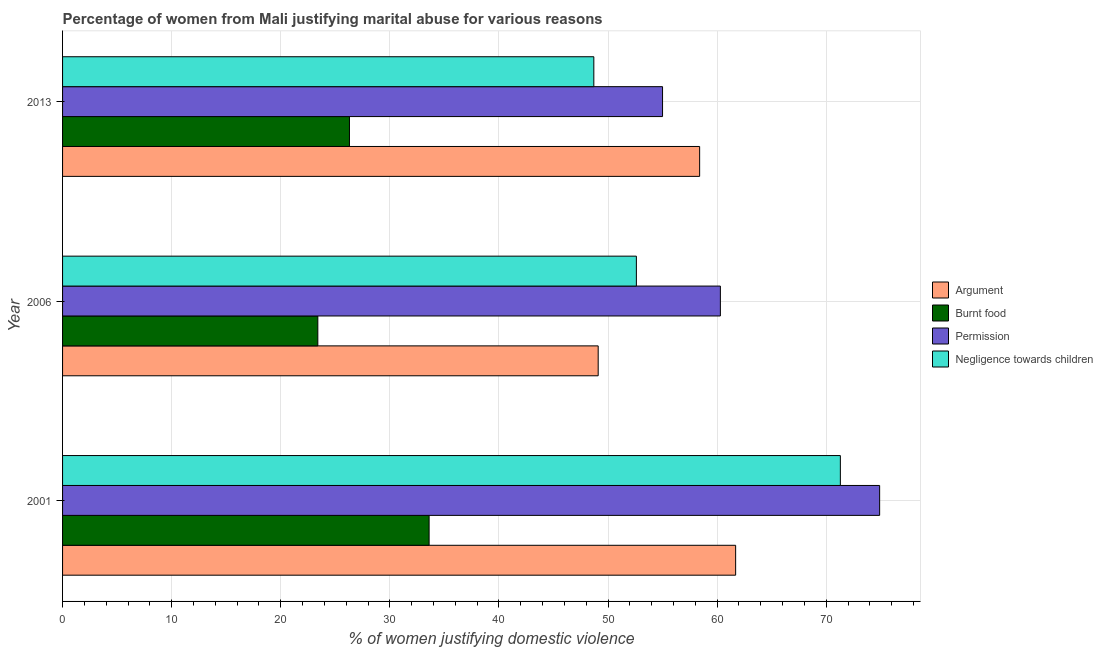How many different coloured bars are there?
Provide a succinct answer. 4. How many groups of bars are there?
Offer a terse response. 3. Are the number of bars per tick equal to the number of legend labels?
Offer a very short reply. Yes. Are the number of bars on each tick of the Y-axis equal?
Your response must be concise. Yes. How many bars are there on the 3rd tick from the bottom?
Your answer should be very brief. 4. In how many cases, is the number of bars for a given year not equal to the number of legend labels?
Provide a succinct answer. 0. What is the percentage of women justifying abuse in the case of an argument in 2001?
Offer a very short reply. 61.7. Across all years, what is the maximum percentage of women justifying abuse in the case of an argument?
Your answer should be very brief. 61.7. Across all years, what is the minimum percentage of women justifying abuse in the case of an argument?
Keep it short and to the point. 49.1. In which year was the percentage of women justifying abuse for burning food maximum?
Offer a terse response. 2001. In which year was the percentage of women justifying abuse for burning food minimum?
Offer a terse response. 2006. What is the total percentage of women justifying abuse in the case of an argument in the graph?
Provide a succinct answer. 169.2. What is the difference between the percentage of women justifying abuse for burning food in 2001 and that in 2013?
Keep it short and to the point. 7.3. What is the difference between the percentage of women justifying abuse in the case of an argument in 2006 and the percentage of women justifying abuse for burning food in 2013?
Provide a succinct answer. 22.8. What is the average percentage of women justifying abuse for burning food per year?
Provide a succinct answer. 27.77. In the year 2001, what is the difference between the percentage of women justifying abuse for burning food and percentage of women justifying abuse in the case of an argument?
Make the answer very short. -28.1. What is the ratio of the percentage of women justifying abuse for burning food in 2006 to that in 2013?
Make the answer very short. 0.89. In how many years, is the percentage of women justifying abuse for showing negligence towards children greater than the average percentage of women justifying abuse for showing negligence towards children taken over all years?
Offer a very short reply. 1. Is the sum of the percentage of women justifying abuse for showing negligence towards children in 2001 and 2006 greater than the maximum percentage of women justifying abuse for burning food across all years?
Offer a terse response. Yes. What does the 3rd bar from the top in 2001 represents?
Your answer should be very brief. Burnt food. What does the 4th bar from the bottom in 2013 represents?
Offer a very short reply. Negligence towards children. How many bars are there?
Your answer should be very brief. 12. How many years are there in the graph?
Make the answer very short. 3. What is the difference between two consecutive major ticks on the X-axis?
Your response must be concise. 10. Where does the legend appear in the graph?
Provide a short and direct response. Center right. How many legend labels are there?
Offer a terse response. 4. What is the title of the graph?
Give a very brief answer. Percentage of women from Mali justifying marital abuse for various reasons. Does "Iceland" appear as one of the legend labels in the graph?
Provide a short and direct response. No. What is the label or title of the X-axis?
Make the answer very short. % of women justifying domestic violence. What is the label or title of the Y-axis?
Provide a succinct answer. Year. What is the % of women justifying domestic violence in Argument in 2001?
Keep it short and to the point. 61.7. What is the % of women justifying domestic violence of Burnt food in 2001?
Provide a short and direct response. 33.6. What is the % of women justifying domestic violence of Permission in 2001?
Keep it short and to the point. 74.9. What is the % of women justifying domestic violence in Negligence towards children in 2001?
Your answer should be very brief. 71.3. What is the % of women justifying domestic violence of Argument in 2006?
Your response must be concise. 49.1. What is the % of women justifying domestic violence in Burnt food in 2006?
Your answer should be compact. 23.4. What is the % of women justifying domestic violence in Permission in 2006?
Your response must be concise. 60.3. What is the % of women justifying domestic violence of Negligence towards children in 2006?
Your response must be concise. 52.6. What is the % of women justifying domestic violence in Argument in 2013?
Provide a short and direct response. 58.4. What is the % of women justifying domestic violence in Burnt food in 2013?
Your answer should be compact. 26.3. What is the % of women justifying domestic violence in Permission in 2013?
Make the answer very short. 55. What is the % of women justifying domestic violence in Negligence towards children in 2013?
Provide a succinct answer. 48.7. Across all years, what is the maximum % of women justifying domestic violence of Argument?
Give a very brief answer. 61.7. Across all years, what is the maximum % of women justifying domestic violence in Burnt food?
Provide a succinct answer. 33.6. Across all years, what is the maximum % of women justifying domestic violence in Permission?
Your response must be concise. 74.9. Across all years, what is the maximum % of women justifying domestic violence in Negligence towards children?
Offer a terse response. 71.3. Across all years, what is the minimum % of women justifying domestic violence of Argument?
Make the answer very short. 49.1. Across all years, what is the minimum % of women justifying domestic violence of Burnt food?
Your response must be concise. 23.4. Across all years, what is the minimum % of women justifying domestic violence of Permission?
Give a very brief answer. 55. Across all years, what is the minimum % of women justifying domestic violence in Negligence towards children?
Give a very brief answer. 48.7. What is the total % of women justifying domestic violence in Argument in the graph?
Your answer should be compact. 169.2. What is the total % of women justifying domestic violence in Burnt food in the graph?
Offer a very short reply. 83.3. What is the total % of women justifying domestic violence in Permission in the graph?
Provide a short and direct response. 190.2. What is the total % of women justifying domestic violence of Negligence towards children in the graph?
Provide a short and direct response. 172.6. What is the difference between the % of women justifying domestic violence in Argument in 2001 and that in 2006?
Provide a short and direct response. 12.6. What is the difference between the % of women justifying domestic violence in Permission in 2001 and that in 2006?
Your answer should be compact. 14.6. What is the difference between the % of women justifying domestic violence in Argument in 2001 and that in 2013?
Your answer should be compact. 3.3. What is the difference between the % of women justifying domestic violence of Negligence towards children in 2001 and that in 2013?
Give a very brief answer. 22.6. What is the difference between the % of women justifying domestic violence of Negligence towards children in 2006 and that in 2013?
Provide a short and direct response. 3.9. What is the difference between the % of women justifying domestic violence in Argument in 2001 and the % of women justifying domestic violence in Burnt food in 2006?
Your response must be concise. 38.3. What is the difference between the % of women justifying domestic violence in Argument in 2001 and the % of women justifying domestic violence in Negligence towards children in 2006?
Your answer should be compact. 9.1. What is the difference between the % of women justifying domestic violence of Burnt food in 2001 and the % of women justifying domestic violence of Permission in 2006?
Offer a terse response. -26.7. What is the difference between the % of women justifying domestic violence of Burnt food in 2001 and the % of women justifying domestic violence of Negligence towards children in 2006?
Ensure brevity in your answer.  -19. What is the difference between the % of women justifying domestic violence in Permission in 2001 and the % of women justifying domestic violence in Negligence towards children in 2006?
Give a very brief answer. 22.3. What is the difference between the % of women justifying domestic violence of Argument in 2001 and the % of women justifying domestic violence of Burnt food in 2013?
Provide a short and direct response. 35.4. What is the difference between the % of women justifying domestic violence in Argument in 2001 and the % of women justifying domestic violence in Negligence towards children in 2013?
Your answer should be compact. 13. What is the difference between the % of women justifying domestic violence of Burnt food in 2001 and the % of women justifying domestic violence of Permission in 2013?
Ensure brevity in your answer.  -21.4. What is the difference between the % of women justifying domestic violence of Burnt food in 2001 and the % of women justifying domestic violence of Negligence towards children in 2013?
Your answer should be very brief. -15.1. What is the difference between the % of women justifying domestic violence of Permission in 2001 and the % of women justifying domestic violence of Negligence towards children in 2013?
Ensure brevity in your answer.  26.2. What is the difference between the % of women justifying domestic violence in Argument in 2006 and the % of women justifying domestic violence in Burnt food in 2013?
Your answer should be very brief. 22.8. What is the difference between the % of women justifying domestic violence in Burnt food in 2006 and the % of women justifying domestic violence in Permission in 2013?
Your answer should be very brief. -31.6. What is the difference between the % of women justifying domestic violence of Burnt food in 2006 and the % of women justifying domestic violence of Negligence towards children in 2013?
Make the answer very short. -25.3. What is the average % of women justifying domestic violence in Argument per year?
Your answer should be compact. 56.4. What is the average % of women justifying domestic violence in Burnt food per year?
Your response must be concise. 27.77. What is the average % of women justifying domestic violence of Permission per year?
Offer a very short reply. 63.4. What is the average % of women justifying domestic violence in Negligence towards children per year?
Ensure brevity in your answer.  57.53. In the year 2001, what is the difference between the % of women justifying domestic violence in Argument and % of women justifying domestic violence in Burnt food?
Offer a terse response. 28.1. In the year 2001, what is the difference between the % of women justifying domestic violence in Burnt food and % of women justifying domestic violence in Permission?
Provide a short and direct response. -41.3. In the year 2001, what is the difference between the % of women justifying domestic violence of Burnt food and % of women justifying domestic violence of Negligence towards children?
Ensure brevity in your answer.  -37.7. In the year 2001, what is the difference between the % of women justifying domestic violence in Permission and % of women justifying domestic violence in Negligence towards children?
Your response must be concise. 3.6. In the year 2006, what is the difference between the % of women justifying domestic violence in Argument and % of women justifying domestic violence in Burnt food?
Offer a terse response. 25.7. In the year 2006, what is the difference between the % of women justifying domestic violence in Argument and % of women justifying domestic violence in Permission?
Give a very brief answer. -11.2. In the year 2006, what is the difference between the % of women justifying domestic violence in Burnt food and % of women justifying domestic violence in Permission?
Provide a short and direct response. -36.9. In the year 2006, what is the difference between the % of women justifying domestic violence of Burnt food and % of women justifying domestic violence of Negligence towards children?
Give a very brief answer. -29.2. In the year 2013, what is the difference between the % of women justifying domestic violence in Argument and % of women justifying domestic violence in Burnt food?
Make the answer very short. 32.1. In the year 2013, what is the difference between the % of women justifying domestic violence in Argument and % of women justifying domestic violence in Permission?
Provide a succinct answer. 3.4. In the year 2013, what is the difference between the % of women justifying domestic violence of Burnt food and % of women justifying domestic violence of Permission?
Your response must be concise. -28.7. In the year 2013, what is the difference between the % of women justifying domestic violence in Burnt food and % of women justifying domestic violence in Negligence towards children?
Give a very brief answer. -22.4. What is the ratio of the % of women justifying domestic violence in Argument in 2001 to that in 2006?
Make the answer very short. 1.26. What is the ratio of the % of women justifying domestic violence in Burnt food in 2001 to that in 2006?
Provide a short and direct response. 1.44. What is the ratio of the % of women justifying domestic violence in Permission in 2001 to that in 2006?
Your response must be concise. 1.24. What is the ratio of the % of women justifying domestic violence of Negligence towards children in 2001 to that in 2006?
Your answer should be very brief. 1.36. What is the ratio of the % of women justifying domestic violence in Argument in 2001 to that in 2013?
Offer a terse response. 1.06. What is the ratio of the % of women justifying domestic violence of Burnt food in 2001 to that in 2013?
Ensure brevity in your answer.  1.28. What is the ratio of the % of women justifying domestic violence in Permission in 2001 to that in 2013?
Provide a succinct answer. 1.36. What is the ratio of the % of women justifying domestic violence in Negligence towards children in 2001 to that in 2013?
Give a very brief answer. 1.46. What is the ratio of the % of women justifying domestic violence of Argument in 2006 to that in 2013?
Keep it short and to the point. 0.84. What is the ratio of the % of women justifying domestic violence in Burnt food in 2006 to that in 2013?
Provide a succinct answer. 0.89. What is the ratio of the % of women justifying domestic violence of Permission in 2006 to that in 2013?
Offer a terse response. 1.1. What is the ratio of the % of women justifying domestic violence of Negligence towards children in 2006 to that in 2013?
Offer a terse response. 1.08. What is the difference between the highest and the second highest % of women justifying domestic violence of Argument?
Your answer should be very brief. 3.3. What is the difference between the highest and the second highest % of women justifying domestic violence in Permission?
Your answer should be very brief. 14.6. What is the difference between the highest and the lowest % of women justifying domestic violence of Argument?
Ensure brevity in your answer.  12.6. What is the difference between the highest and the lowest % of women justifying domestic violence of Burnt food?
Your response must be concise. 10.2. What is the difference between the highest and the lowest % of women justifying domestic violence of Permission?
Ensure brevity in your answer.  19.9. What is the difference between the highest and the lowest % of women justifying domestic violence in Negligence towards children?
Provide a succinct answer. 22.6. 